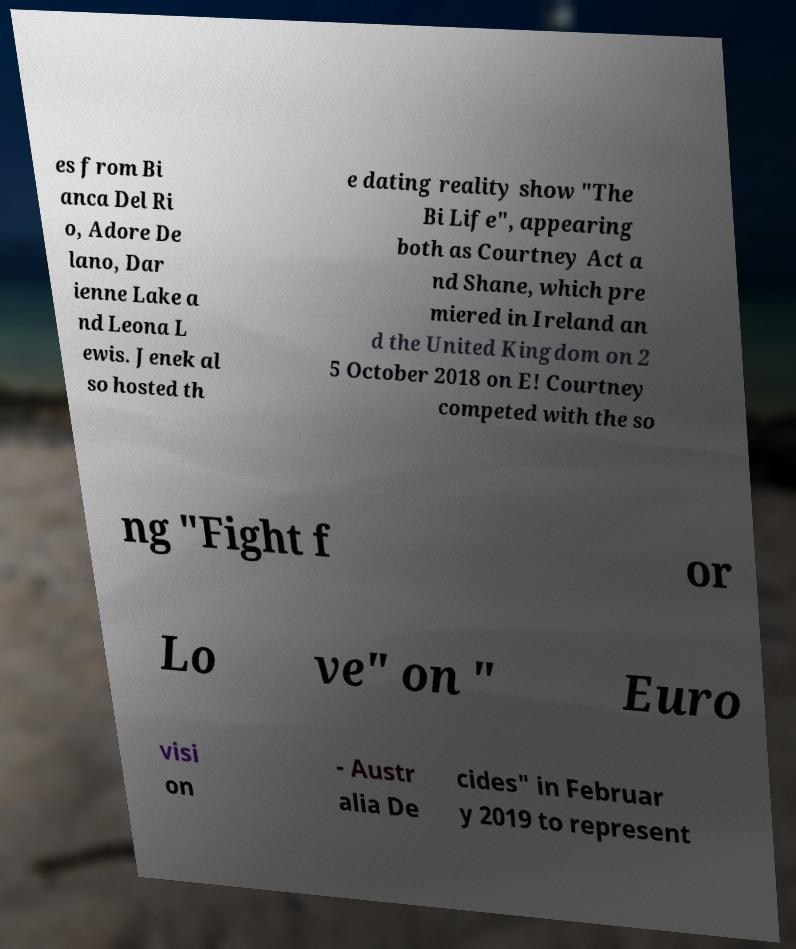For documentation purposes, I need the text within this image transcribed. Could you provide that? es from Bi anca Del Ri o, Adore De lano, Dar ienne Lake a nd Leona L ewis. Jenek al so hosted th e dating reality show "The Bi Life", appearing both as Courtney Act a nd Shane, which pre miered in Ireland an d the United Kingdom on 2 5 October 2018 on E! Courtney competed with the so ng "Fight f or Lo ve" on " Euro visi on - Austr alia De cides" in Februar y 2019 to represent 